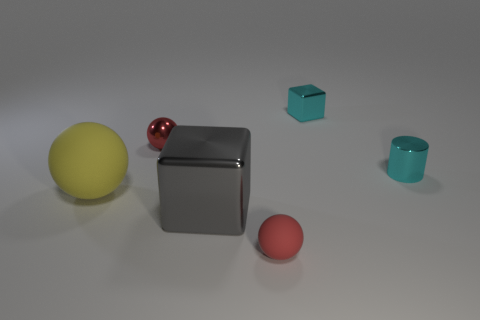What size is the thing that is the same color as the small metallic cylinder?
Your response must be concise. Small. There is another small ball that is the same color as the tiny shiny sphere; what material is it?
Your response must be concise. Rubber. Do the yellow object and the red rubber object have the same shape?
Your answer should be very brief. Yes. What is the tiny sphere that is in front of the tiny shiny object that is on the right side of the tiny cyan cube made of?
Your answer should be very brief. Rubber. Is the large sphere made of the same material as the tiny red ball on the right side of the big gray block?
Provide a succinct answer. Yes. How many spheres are left of the red sphere that is to the right of the red shiny sphere that is to the right of the yellow thing?
Keep it short and to the point. 2. Are there fewer small red matte objects to the right of the tiny red matte ball than spheres behind the large sphere?
Keep it short and to the point. Yes. How many other things are there of the same material as the large cube?
Ensure brevity in your answer.  3. What material is the other red sphere that is the same size as the red shiny ball?
Provide a succinct answer. Rubber. What number of gray things are large blocks or tiny cylinders?
Provide a succinct answer. 1. 